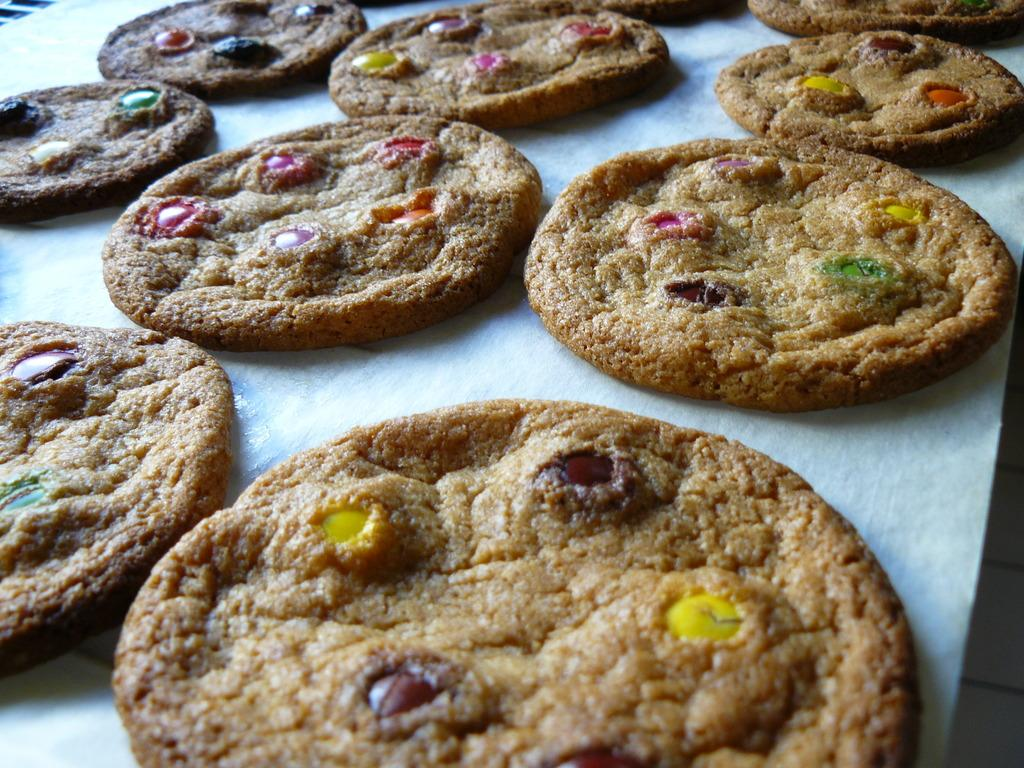What type of food can be seen in the image? There are cookies in the image. How are the cookies arranged or placed in the image? The cookies are on a tissue. What type of cord is connected to the school machine in the image? There is no cord, school, or machine present in the image; it only features cookies on a tissue. 